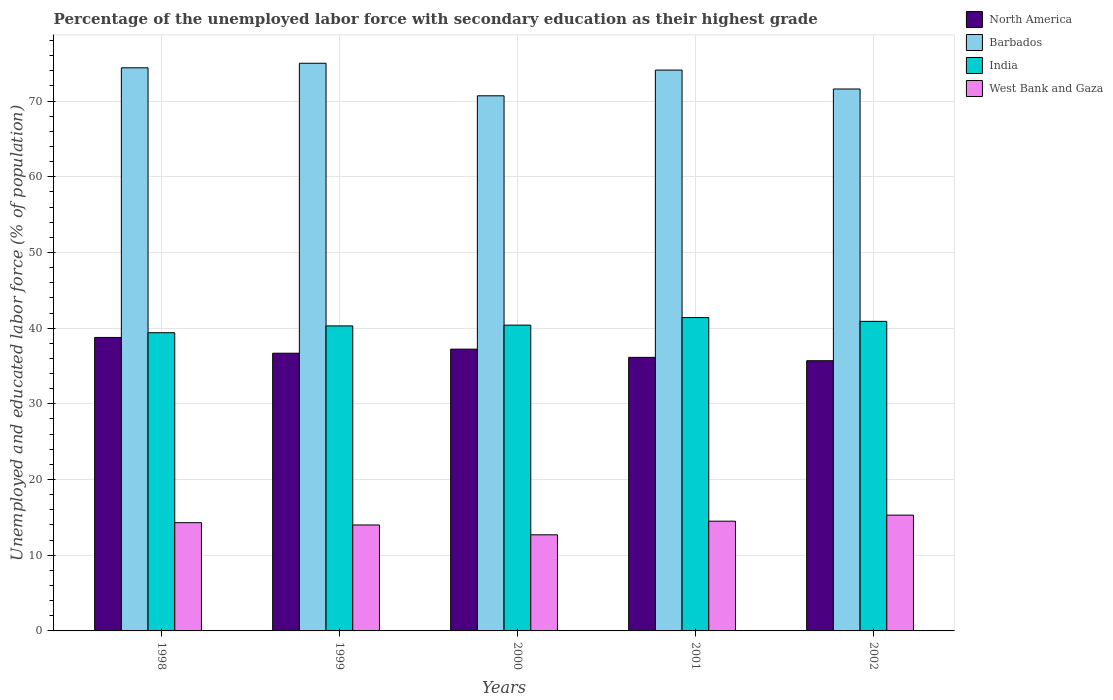How many different coloured bars are there?
Your answer should be compact. 4. Are the number of bars on each tick of the X-axis equal?
Provide a succinct answer. Yes. How many bars are there on the 4th tick from the right?
Your answer should be very brief. 4. What is the label of the 5th group of bars from the left?
Provide a short and direct response. 2002. What is the percentage of the unemployed labor force with secondary education in North America in 2001?
Provide a short and direct response. 36.14. Across all years, what is the maximum percentage of the unemployed labor force with secondary education in India?
Keep it short and to the point. 41.4. Across all years, what is the minimum percentage of the unemployed labor force with secondary education in West Bank and Gaza?
Offer a very short reply. 12.7. In which year was the percentage of the unemployed labor force with secondary education in West Bank and Gaza maximum?
Your response must be concise. 2002. In which year was the percentage of the unemployed labor force with secondary education in India minimum?
Provide a short and direct response. 1998. What is the total percentage of the unemployed labor force with secondary education in North America in the graph?
Make the answer very short. 184.53. What is the difference between the percentage of the unemployed labor force with secondary education in Barbados in 1998 and that in 2002?
Your answer should be compact. 2.8. What is the difference between the percentage of the unemployed labor force with secondary education in Barbados in 2000 and the percentage of the unemployed labor force with secondary education in West Bank and Gaza in 1998?
Provide a succinct answer. 56.4. What is the average percentage of the unemployed labor force with secondary education in India per year?
Provide a succinct answer. 40.48. In the year 1999, what is the difference between the percentage of the unemployed labor force with secondary education in Barbados and percentage of the unemployed labor force with secondary education in India?
Offer a terse response. 34.7. What is the ratio of the percentage of the unemployed labor force with secondary education in West Bank and Gaza in 1998 to that in 1999?
Offer a very short reply. 1.02. Is the percentage of the unemployed labor force with secondary education in North America in 1998 less than that in 2000?
Your response must be concise. No. Is the difference between the percentage of the unemployed labor force with secondary education in Barbados in 1998 and 2001 greater than the difference between the percentage of the unemployed labor force with secondary education in India in 1998 and 2001?
Keep it short and to the point. Yes. What is the difference between the highest and the second highest percentage of the unemployed labor force with secondary education in North America?
Ensure brevity in your answer.  1.55. What is the difference between the highest and the lowest percentage of the unemployed labor force with secondary education in North America?
Keep it short and to the point. 3.07. What does the 4th bar from the left in 2002 represents?
Your answer should be very brief. West Bank and Gaza. What does the 3rd bar from the right in 2001 represents?
Ensure brevity in your answer.  Barbados. Is it the case that in every year, the sum of the percentage of the unemployed labor force with secondary education in Barbados and percentage of the unemployed labor force with secondary education in North America is greater than the percentage of the unemployed labor force with secondary education in India?
Offer a very short reply. Yes. Are all the bars in the graph horizontal?
Provide a succinct answer. No. What is the difference between two consecutive major ticks on the Y-axis?
Offer a very short reply. 10. Does the graph contain any zero values?
Your response must be concise. No. Does the graph contain grids?
Give a very brief answer. Yes. Where does the legend appear in the graph?
Offer a terse response. Top right. How many legend labels are there?
Provide a short and direct response. 4. How are the legend labels stacked?
Offer a terse response. Vertical. What is the title of the graph?
Your answer should be compact. Percentage of the unemployed labor force with secondary education as their highest grade. What is the label or title of the X-axis?
Your answer should be very brief. Years. What is the label or title of the Y-axis?
Provide a short and direct response. Unemployed and educated labor force (% of population). What is the Unemployed and educated labor force (% of population) of North America in 1998?
Make the answer very short. 38.77. What is the Unemployed and educated labor force (% of population) of Barbados in 1998?
Give a very brief answer. 74.4. What is the Unemployed and educated labor force (% of population) of India in 1998?
Your response must be concise. 39.4. What is the Unemployed and educated labor force (% of population) in West Bank and Gaza in 1998?
Your answer should be very brief. 14.3. What is the Unemployed and educated labor force (% of population) in North America in 1999?
Provide a succinct answer. 36.69. What is the Unemployed and educated labor force (% of population) in India in 1999?
Your answer should be very brief. 40.3. What is the Unemployed and educated labor force (% of population) of North America in 2000?
Your response must be concise. 37.23. What is the Unemployed and educated labor force (% of population) in Barbados in 2000?
Your response must be concise. 70.7. What is the Unemployed and educated labor force (% of population) in India in 2000?
Your answer should be compact. 40.4. What is the Unemployed and educated labor force (% of population) of West Bank and Gaza in 2000?
Keep it short and to the point. 12.7. What is the Unemployed and educated labor force (% of population) in North America in 2001?
Give a very brief answer. 36.14. What is the Unemployed and educated labor force (% of population) of Barbados in 2001?
Your answer should be compact. 74.1. What is the Unemployed and educated labor force (% of population) in India in 2001?
Offer a very short reply. 41.4. What is the Unemployed and educated labor force (% of population) in West Bank and Gaza in 2001?
Your answer should be compact. 14.5. What is the Unemployed and educated labor force (% of population) of North America in 2002?
Provide a succinct answer. 35.7. What is the Unemployed and educated labor force (% of population) in Barbados in 2002?
Offer a very short reply. 71.6. What is the Unemployed and educated labor force (% of population) in India in 2002?
Your response must be concise. 40.9. What is the Unemployed and educated labor force (% of population) in West Bank and Gaza in 2002?
Offer a terse response. 15.3. Across all years, what is the maximum Unemployed and educated labor force (% of population) in North America?
Make the answer very short. 38.77. Across all years, what is the maximum Unemployed and educated labor force (% of population) in India?
Ensure brevity in your answer.  41.4. Across all years, what is the maximum Unemployed and educated labor force (% of population) of West Bank and Gaza?
Your answer should be compact. 15.3. Across all years, what is the minimum Unemployed and educated labor force (% of population) of North America?
Ensure brevity in your answer.  35.7. Across all years, what is the minimum Unemployed and educated labor force (% of population) of Barbados?
Provide a short and direct response. 70.7. Across all years, what is the minimum Unemployed and educated labor force (% of population) in India?
Your answer should be compact. 39.4. Across all years, what is the minimum Unemployed and educated labor force (% of population) in West Bank and Gaza?
Offer a very short reply. 12.7. What is the total Unemployed and educated labor force (% of population) of North America in the graph?
Provide a short and direct response. 184.53. What is the total Unemployed and educated labor force (% of population) in Barbados in the graph?
Your answer should be very brief. 365.8. What is the total Unemployed and educated labor force (% of population) of India in the graph?
Your response must be concise. 202.4. What is the total Unemployed and educated labor force (% of population) in West Bank and Gaza in the graph?
Your answer should be very brief. 70.8. What is the difference between the Unemployed and educated labor force (% of population) of North America in 1998 and that in 1999?
Offer a very short reply. 2.08. What is the difference between the Unemployed and educated labor force (% of population) of North America in 1998 and that in 2000?
Offer a terse response. 1.55. What is the difference between the Unemployed and educated labor force (% of population) in India in 1998 and that in 2000?
Keep it short and to the point. -1. What is the difference between the Unemployed and educated labor force (% of population) of West Bank and Gaza in 1998 and that in 2000?
Provide a short and direct response. 1.6. What is the difference between the Unemployed and educated labor force (% of population) in North America in 1998 and that in 2001?
Offer a terse response. 2.63. What is the difference between the Unemployed and educated labor force (% of population) of India in 1998 and that in 2001?
Provide a succinct answer. -2. What is the difference between the Unemployed and educated labor force (% of population) of West Bank and Gaza in 1998 and that in 2001?
Keep it short and to the point. -0.2. What is the difference between the Unemployed and educated labor force (% of population) of North America in 1998 and that in 2002?
Offer a terse response. 3.07. What is the difference between the Unemployed and educated labor force (% of population) in India in 1998 and that in 2002?
Offer a terse response. -1.5. What is the difference between the Unemployed and educated labor force (% of population) in West Bank and Gaza in 1998 and that in 2002?
Ensure brevity in your answer.  -1. What is the difference between the Unemployed and educated labor force (% of population) in North America in 1999 and that in 2000?
Keep it short and to the point. -0.54. What is the difference between the Unemployed and educated labor force (% of population) in India in 1999 and that in 2000?
Your answer should be very brief. -0.1. What is the difference between the Unemployed and educated labor force (% of population) in North America in 1999 and that in 2001?
Ensure brevity in your answer.  0.55. What is the difference between the Unemployed and educated labor force (% of population) in India in 1999 and that in 2002?
Give a very brief answer. -0.6. What is the difference between the Unemployed and educated labor force (% of population) in West Bank and Gaza in 1999 and that in 2002?
Provide a succinct answer. -1.3. What is the difference between the Unemployed and educated labor force (% of population) of North America in 2000 and that in 2001?
Your answer should be very brief. 1.08. What is the difference between the Unemployed and educated labor force (% of population) of Barbados in 2000 and that in 2001?
Provide a succinct answer. -3.4. What is the difference between the Unemployed and educated labor force (% of population) in India in 2000 and that in 2001?
Provide a succinct answer. -1. What is the difference between the Unemployed and educated labor force (% of population) of West Bank and Gaza in 2000 and that in 2001?
Make the answer very short. -1.8. What is the difference between the Unemployed and educated labor force (% of population) of North America in 2000 and that in 2002?
Keep it short and to the point. 1.53. What is the difference between the Unemployed and educated labor force (% of population) in Barbados in 2000 and that in 2002?
Give a very brief answer. -0.9. What is the difference between the Unemployed and educated labor force (% of population) in India in 2000 and that in 2002?
Make the answer very short. -0.5. What is the difference between the Unemployed and educated labor force (% of population) in West Bank and Gaza in 2000 and that in 2002?
Offer a very short reply. -2.6. What is the difference between the Unemployed and educated labor force (% of population) of North America in 2001 and that in 2002?
Your response must be concise. 0.44. What is the difference between the Unemployed and educated labor force (% of population) in West Bank and Gaza in 2001 and that in 2002?
Your answer should be compact. -0.8. What is the difference between the Unemployed and educated labor force (% of population) of North America in 1998 and the Unemployed and educated labor force (% of population) of Barbados in 1999?
Keep it short and to the point. -36.23. What is the difference between the Unemployed and educated labor force (% of population) in North America in 1998 and the Unemployed and educated labor force (% of population) in India in 1999?
Offer a terse response. -1.53. What is the difference between the Unemployed and educated labor force (% of population) in North America in 1998 and the Unemployed and educated labor force (% of population) in West Bank and Gaza in 1999?
Offer a very short reply. 24.77. What is the difference between the Unemployed and educated labor force (% of population) in Barbados in 1998 and the Unemployed and educated labor force (% of population) in India in 1999?
Make the answer very short. 34.1. What is the difference between the Unemployed and educated labor force (% of population) in Barbados in 1998 and the Unemployed and educated labor force (% of population) in West Bank and Gaza in 1999?
Ensure brevity in your answer.  60.4. What is the difference between the Unemployed and educated labor force (% of population) in India in 1998 and the Unemployed and educated labor force (% of population) in West Bank and Gaza in 1999?
Provide a short and direct response. 25.4. What is the difference between the Unemployed and educated labor force (% of population) in North America in 1998 and the Unemployed and educated labor force (% of population) in Barbados in 2000?
Provide a succinct answer. -31.93. What is the difference between the Unemployed and educated labor force (% of population) of North America in 1998 and the Unemployed and educated labor force (% of population) of India in 2000?
Keep it short and to the point. -1.63. What is the difference between the Unemployed and educated labor force (% of population) in North America in 1998 and the Unemployed and educated labor force (% of population) in West Bank and Gaza in 2000?
Offer a terse response. 26.07. What is the difference between the Unemployed and educated labor force (% of population) of Barbados in 1998 and the Unemployed and educated labor force (% of population) of India in 2000?
Give a very brief answer. 34. What is the difference between the Unemployed and educated labor force (% of population) in Barbados in 1998 and the Unemployed and educated labor force (% of population) in West Bank and Gaza in 2000?
Ensure brevity in your answer.  61.7. What is the difference between the Unemployed and educated labor force (% of population) in India in 1998 and the Unemployed and educated labor force (% of population) in West Bank and Gaza in 2000?
Offer a terse response. 26.7. What is the difference between the Unemployed and educated labor force (% of population) of North America in 1998 and the Unemployed and educated labor force (% of population) of Barbados in 2001?
Ensure brevity in your answer.  -35.33. What is the difference between the Unemployed and educated labor force (% of population) of North America in 1998 and the Unemployed and educated labor force (% of population) of India in 2001?
Offer a terse response. -2.63. What is the difference between the Unemployed and educated labor force (% of population) in North America in 1998 and the Unemployed and educated labor force (% of population) in West Bank and Gaza in 2001?
Offer a terse response. 24.27. What is the difference between the Unemployed and educated labor force (% of population) of Barbados in 1998 and the Unemployed and educated labor force (% of population) of India in 2001?
Your answer should be very brief. 33. What is the difference between the Unemployed and educated labor force (% of population) of Barbados in 1998 and the Unemployed and educated labor force (% of population) of West Bank and Gaza in 2001?
Keep it short and to the point. 59.9. What is the difference between the Unemployed and educated labor force (% of population) of India in 1998 and the Unemployed and educated labor force (% of population) of West Bank and Gaza in 2001?
Provide a succinct answer. 24.9. What is the difference between the Unemployed and educated labor force (% of population) of North America in 1998 and the Unemployed and educated labor force (% of population) of Barbados in 2002?
Give a very brief answer. -32.83. What is the difference between the Unemployed and educated labor force (% of population) in North America in 1998 and the Unemployed and educated labor force (% of population) in India in 2002?
Ensure brevity in your answer.  -2.13. What is the difference between the Unemployed and educated labor force (% of population) in North America in 1998 and the Unemployed and educated labor force (% of population) in West Bank and Gaza in 2002?
Offer a very short reply. 23.47. What is the difference between the Unemployed and educated labor force (% of population) of Barbados in 1998 and the Unemployed and educated labor force (% of population) of India in 2002?
Offer a very short reply. 33.5. What is the difference between the Unemployed and educated labor force (% of population) in Barbados in 1998 and the Unemployed and educated labor force (% of population) in West Bank and Gaza in 2002?
Your answer should be compact. 59.1. What is the difference between the Unemployed and educated labor force (% of population) in India in 1998 and the Unemployed and educated labor force (% of population) in West Bank and Gaza in 2002?
Make the answer very short. 24.1. What is the difference between the Unemployed and educated labor force (% of population) in North America in 1999 and the Unemployed and educated labor force (% of population) in Barbados in 2000?
Offer a terse response. -34.01. What is the difference between the Unemployed and educated labor force (% of population) of North America in 1999 and the Unemployed and educated labor force (% of population) of India in 2000?
Your answer should be very brief. -3.71. What is the difference between the Unemployed and educated labor force (% of population) in North America in 1999 and the Unemployed and educated labor force (% of population) in West Bank and Gaza in 2000?
Your answer should be compact. 23.99. What is the difference between the Unemployed and educated labor force (% of population) of Barbados in 1999 and the Unemployed and educated labor force (% of population) of India in 2000?
Make the answer very short. 34.6. What is the difference between the Unemployed and educated labor force (% of population) of Barbados in 1999 and the Unemployed and educated labor force (% of population) of West Bank and Gaza in 2000?
Offer a very short reply. 62.3. What is the difference between the Unemployed and educated labor force (% of population) in India in 1999 and the Unemployed and educated labor force (% of population) in West Bank and Gaza in 2000?
Your answer should be compact. 27.6. What is the difference between the Unemployed and educated labor force (% of population) of North America in 1999 and the Unemployed and educated labor force (% of population) of Barbados in 2001?
Ensure brevity in your answer.  -37.41. What is the difference between the Unemployed and educated labor force (% of population) of North America in 1999 and the Unemployed and educated labor force (% of population) of India in 2001?
Your answer should be very brief. -4.71. What is the difference between the Unemployed and educated labor force (% of population) of North America in 1999 and the Unemployed and educated labor force (% of population) of West Bank and Gaza in 2001?
Provide a short and direct response. 22.19. What is the difference between the Unemployed and educated labor force (% of population) of Barbados in 1999 and the Unemployed and educated labor force (% of population) of India in 2001?
Offer a terse response. 33.6. What is the difference between the Unemployed and educated labor force (% of population) in Barbados in 1999 and the Unemployed and educated labor force (% of population) in West Bank and Gaza in 2001?
Your answer should be compact. 60.5. What is the difference between the Unemployed and educated labor force (% of population) in India in 1999 and the Unemployed and educated labor force (% of population) in West Bank and Gaza in 2001?
Offer a terse response. 25.8. What is the difference between the Unemployed and educated labor force (% of population) of North America in 1999 and the Unemployed and educated labor force (% of population) of Barbados in 2002?
Offer a very short reply. -34.91. What is the difference between the Unemployed and educated labor force (% of population) in North America in 1999 and the Unemployed and educated labor force (% of population) in India in 2002?
Make the answer very short. -4.21. What is the difference between the Unemployed and educated labor force (% of population) in North America in 1999 and the Unemployed and educated labor force (% of population) in West Bank and Gaza in 2002?
Keep it short and to the point. 21.39. What is the difference between the Unemployed and educated labor force (% of population) of Barbados in 1999 and the Unemployed and educated labor force (% of population) of India in 2002?
Provide a short and direct response. 34.1. What is the difference between the Unemployed and educated labor force (% of population) in Barbados in 1999 and the Unemployed and educated labor force (% of population) in West Bank and Gaza in 2002?
Provide a short and direct response. 59.7. What is the difference between the Unemployed and educated labor force (% of population) in India in 1999 and the Unemployed and educated labor force (% of population) in West Bank and Gaza in 2002?
Make the answer very short. 25. What is the difference between the Unemployed and educated labor force (% of population) of North America in 2000 and the Unemployed and educated labor force (% of population) of Barbados in 2001?
Provide a short and direct response. -36.87. What is the difference between the Unemployed and educated labor force (% of population) in North America in 2000 and the Unemployed and educated labor force (% of population) in India in 2001?
Keep it short and to the point. -4.17. What is the difference between the Unemployed and educated labor force (% of population) in North America in 2000 and the Unemployed and educated labor force (% of population) in West Bank and Gaza in 2001?
Make the answer very short. 22.73. What is the difference between the Unemployed and educated labor force (% of population) of Barbados in 2000 and the Unemployed and educated labor force (% of population) of India in 2001?
Your response must be concise. 29.3. What is the difference between the Unemployed and educated labor force (% of population) of Barbados in 2000 and the Unemployed and educated labor force (% of population) of West Bank and Gaza in 2001?
Keep it short and to the point. 56.2. What is the difference between the Unemployed and educated labor force (% of population) of India in 2000 and the Unemployed and educated labor force (% of population) of West Bank and Gaza in 2001?
Keep it short and to the point. 25.9. What is the difference between the Unemployed and educated labor force (% of population) of North America in 2000 and the Unemployed and educated labor force (% of population) of Barbados in 2002?
Provide a short and direct response. -34.37. What is the difference between the Unemployed and educated labor force (% of population) of North America in 2000 and the Unemployed and educated labor force (% of population) of India in 2002?
Keep it short and to the point. -3.67. What is the difference between the Unemployed and educated labor force (% of population) of North America in 2000 and the Unemployed and educated labor force (% of population) of West Bank and Gaza in 2002?
Offer a terse response. 21.93. What is the difference between the Unemployed and educated labor force (% of population) of Barbados in 2000 and the Unemployed and educated labor force (% of population) of India in 2002?
Make the answer very short. 29.8. What is the difference between the Unemployed and educated labor force (% of population) in Barbados in 2000 and the Unemployed and educated labor force (% of population) in West Bank and Gaza in 2002?
Make the answer very short. 55.4. What is the difference between the Unemployed and educated labor force (% of population) in India in 2000 and the Unemployed and educated labor force (% of population) in West Bank and Gaza in 2002?
Provide a succinct answer. 25.1. What is the difference between the Unemployed and educated labor force (% of population) in North America in 2001 and the Unemployed and educated labor force (% of population) in Barbados in 2002?
Offer a very short reply. -35.46. What is the difference between the Unemployed and educated labor force (% of population) of North America in 2001 and the Unemployed and educated labor force (% of population) of India in 2002?
Offer a terse response. -4.76. What is the difference between the Unemployed and educated labor force (% of population) in North America in 2001 and the Unemployed and educated labor force (% of population) in West Bank and Gaza in 2002?
Keep it short and to the point. 20.84. What is the difference between the Unemployed and educated labor force (% of population) of Barbados in 2001 and the Unemployed and educated labor force (% of population) of India in 2002?
Provide a short and direct response. 33.2. What is the difference between the Unemployed and educated labor force (% of population) of Barbados in 2001 and the Unemployed and educated labor force (% of population) of West Bank and Gaza in 2002?
Provide a succinct answer. 58.8. What is the difference between the Unemployed and educated labor force (% of population) in India in 2001 and the Unemployed and educated labor force (% of population) in West Bank and Gaza in 2002?
Offer a very short reply. 26.1. What is the average Unemployed and educated labor force (% of population) in North America per year?
Offer a very short reply. 36.91. What is the average Unemployed and educated labor force (% of population) of Barbados per year?
Your answer should be compact. 73.16. What is the average Unemployed and educated labor force (% of population) in India per year?
Your response must be concise. 40.48. What is the average Unemployed and educated labor force (% of population) of West Bank and Gaza per year?
Ensure brevity in your answer.  14.16. In the year 1998, what is the difference between the Unemployed and educated labor force (% of population) of North America and Unemployed and educated labor force (% of population) of Barbados?
Provide a short and direct response. -35.63. In the year 1998, what is the difference between the Unemployed and educated labor force (% of population) of North America and Unemployed and educated labor force (% of population) of India?
Provide a succinct answer. -0.63. In the year 1998, what is the difference between the Unemployed and educated labor force (% of population) in North America and Unemployed and educated labor force (% of population) in West Bank and Gaza?
Keep it short and to the point. 24.47. In the year 1998, what is the difference between the Unemployed and educated labor force (% of population) in Barbados and Unemployed and educated labor force (% of population) in India?
Your answer should be compact. 35. In the year 1998, what is the difference between the Unemployed and educated labor force (% of population) in Barbados and Unemployed and educated labor force (% of population) in West Bank and Gaza?
Your answer should be compact. 60.1. In the year 1998, what is the difference between the Unemployed and educated labor force (% of population) in India and Unemployed and educated labor force (% of population) in West Bank and Gaza?
Offer a very short reply. 25.1. In the year 1999, what is the difference between the Unemployed and educated labor force (% of population) in North America and Unemployed and educated labor force (% of population) in Barbados?
Ensure brevity in your answer.  -38.31. In the year 1999, what is the difference between the Unemployed and educated labor force (% of population) of North America and Unemployed and educated labor force (% of population) of India?
Your response must be concise. -3.61. In the year 1999, what is the difference between the Unemployed and educated labor force (% of population) in North America and Unemployed and educated labor force (% of population) in West Bank and Gaza?
Make the answer very short. 22.69. In the year 1999, what is the difference between the Unemployed and educated labor force (% of population) in Barbados and Unemployed and educated labor force (% of population) in India?
Keep it short and to the point. 34.7. In the year 1999, what is the difference between the Unemployed and educated labor force (% of population) in India and Unemployed and educated labor force (% of population) in West Bank and Gaza?
Offer a terse response. 26.3. In the year 2000, what is the difference between the Unemployed and educated labor force (% of population) in North America and Unemployed and educated labor force (% of population) in Barbados?
Your answer should be very brief. -33.47. In the year 2000, what is the difference between the Unemployed and educated labor force (% of population) of North America and Unemployed and educated labor force (% of population) of India?
Keep it short and to the point. -3.17. In the year 2000, what is the difference between the Unemployed and educated labor force (% of population) of North America and Unemployed and educated labor force (% of population) of West Bank and Gaza?
Make the answer very short. 24.53. In the year 2000, what is the difference between the Unemployed and educated labor force (% of population) in Barbados and Unemployed and educated labor force (% of population) in India?
Ensure brevity in your answer.  30.3. In the year 2000, what is the difference between the Unemployed and educated labor force (% of population) of Barbados and Unemployed and educated labor force (% of population) of West Bank and Gaza?
Give a very brief answer. 58. In the year 2000, what is the difference between the Unemployed and educated labor force (% of population) in India and Unemployed and educated labor force (% of population) in West Bank and Gaza?
Offer a very short reply. 27.7. In the year 2001, what is the difference between the Unemployed and educated labor force (% of population) of North America and Unemployed and educated labor force (% of population) of Barbados?
Provide a short and direct response. -37.96. In the year 2001, what is the difference between the Unemployed and educated labor force (% of population) of North America and Unemployed and educated labor force (% of population) of India?
Your answer should be compact. -5.26. In the year 2001, what is the difference between the Unemployed and educated labor force (% of population) of North America and Unemployed and educated labor force (% of population) of West Bank and Gaza?
Your answer should be compact. 21.64. In the year 2001, what is the difference between the Unemployed and educated labor force (% of population) of Barbados and Unemployed and educated labor force (% of population) of India?
Keep it short and to the point. 32.7. In the year 2001, what is the difference between the Unemployed and educated labor force (% of population) of Barbados and Unemployed and educated labor force (% of population) of West Bank and Gaza?
Keep it short and to the point. 59.6. In the year 2001, what is the difference between the Unemployed and educated labor force (% of population) in India and Unemployed and educated labor force (% of population) in West Bank and Gaza?
Your answer should be very brief. 26.9. In the year 2002, what is the difference between the Unemployed and educated labor force (% of population) in North America and Unemployed and educated labor force (% of population) in Barbados?
Your response must be concise. -35.9. In the year 2002, what is the difference between the Unemployed and educated labor force (% of population) of North America and Unemployed and educated labor force (% of population) of India?
Your response must be concise. -5.2. In the year 2002, what is the difference between the Unemployed and educated labor force (% of population) of North America and Unemployed and educated labor force (% of population) of West Bank and Gaza?
Your answer should be compact. 20.4. In the year 2002, what is the difference between the Unemployed and educated labor force (% of population) in Barbados and Unemployed and educated labor force (% of population) in India?
Make the answer very short. 30.7. In the year 2002, what is the difference between the Unemployed and educated labor force (% of population) of Barbados and Unemployed and educated labor force (% of population) of West Bank and Gaza?
Offer a very short reply. 56.3. In the year 2002, what is the difference between the Unemployed and educated labor force (% of population) in India and Unemployed and educated labor force (% of population) in West Bank and Gaza?
Offer a terse response. 25.6. What is the ratio of the Unemployed and educated labor force (% of population) of North America in 1998 to that in 1999?
Offer a terse response. 1.06. What is the ratio of the Unemployed and educated labor force (% of population) of India in 1998 to that in 1999?
Offer a very short reply. 0.98. What is the ratio of the Unemployed and educated labor force (% of population) of West Bank and Gaza in 1998 to that in 1999?
Give a very brief answer. 1.02. What is the ratio of the Unemployed and educated labor force (% of population) of North America in 1998 to that in 2000?
Your response must be concise. 1.04. What is the ratio of the Unemployed and educated labor force (% of population) of Barbados in 1998 to that in 2000?
Your answer should be very brief. 1.05. What is the ratio of the Unemployed and educated labor force (% of population) in India in 1998 to that in 2000?
Your answer should be compact. 0.98. What is the ratio of the Unemployed and educated labor force (% of population) in West Bank and Gaza in 1998 to that in 2000?
Keep it short and to the point. 1.13. What is the ratio of the Unemployed and educated labor force (% of population) of North America in 1998 to that in 2001?
Offer a terse response. 1.07. What is the ratio of the Unemployed and educated labor force (% of population) in India in 1998 to that in 2001?
Keep it short and to the point. 0.95. What is the ratio of the Unemployed and educated labor force (% of population) of West Bank and Gaza in 1998 to that in 2001?
Offer a very short reply. 0.99. What is the ratio of the Unemployed and educated labor force (% of population) in North America in 1998 to that in 2002?
Offer a very short reply. 1.09. What is the ratio of the Unemployed and educated labor force (% of population) of Barbados in 1998 to that in 2002?
Your response must be concise. 1.04. What is the ratio of the Unemployed and educated labor force (% of population) of India in 1998 to that in 2002?
Make the answer very short. 0.96. What is the ratio of the Unemployed and educated labor force (% of population) of West Bank and Gaza in 1998 to that in 2002?
Your answer should be very brief. 0.93. What is the ratio of the Unemployed and educated labor force (% of population) of North America in 1999 to that in 2000?
Give a very brief answer. 0.99. What is the ratio of the Unemployed and educated labor force (% of population) of Barbados in 1999 to that in 2000?
Provide a short and direct response. 1.06. What is the ratio of the Unemployed and educated labor force (% of population) in West Bank and Gaza in 1999 to that in 2000?
Your answer should be very brief. 1.1. What is the ratio of the Unemployed and educated labor force (% of population) in North America in 1999 to that in 2001?
Keep it short and to the point. 1.02. What is the ratio of the Unemployed and educated labor force (% of population) of Barbados in 1999 to that in 2001?
Make the answer very short. 1.01. What is the ratio of the Unemployed and educated labor force (% of population) of India in 1999 to that in 2001?
Give a very brief answer. 0.97. What is the ratio of the Unemployed and educated labor force (% of population) in West Bank and Gaza in 1999 to that in 2001?
Your response must be concise. 0.97. What is the ratio of the Unemployed and educated labor force (% of population) in North America in 1999 to that in 2002?
Give a very brief answer. 1.03. What is the ratio of the Unemployed and educated labor force (% of population) in Barbados in 1999 to that in 2002?
Provide a succinct answer. 1.05. What is the ratio of the Unemployed and educated labor force (% of population) in India in 1999 to that in 2002?
Keep it short and to the point. 0.99. What is the ratio of the Unemployed and educated labor force (% of population) of West Bank and Gaza in 1999 to that in 2002?
Ensure brevity in your answer.  0.92. What is the ratio of the Unemployed and educated labor force (% of population) of North America in 2000 to that in 2001?
Ensure brevity in your answer.  1.03. What is the ratio of the Unemployed and educated labor force (% of population) in Barbados in 2000 to that in 2001?
Your response must be concise. 0.95. What is the ratio of the Unemployed and educated labor force (% of population) in India in 2000 to that in 2001?
Offer a terse response. 0.98. What is the ratio of the Unemployed and educated labor force (% of population) of West Bank and Gaza in 2000 to that in 2001?
Your answer should be compact. 0.88. What is the ratio of the Unemployed and educated labor force (% of population) in North America in 2000 to that in 2002?
Provide a succinct answer. 1.04. What is the ratio of the Unemployed and educated labor force (% of population) in Barbados in 2000 to that in 2002?
Ensure brevity in your answer.  0.99. What is the ratio of the Unemployed and educated labor force (% of population) in West Bank and Gaza in 2000 to that in 2002?
Offer a very short reply. 0.83. What is the ratio of the Unemployed and educated labor force (% of population) of North America in 2001 to that in 2002?
Ensure brevity in your answer.  1.01. What is the ratio of the Unemployed and educated labor force (% of population) of Barbados in 2001 to that in 2002?
Offer a very short reply. 1.03. What is the ratio of the Unemployed and educated labor force (% of population) in India in 2001 to that in 2002?
Offer a very short reply. 1.01. What is the ratio of the Unemployed and educated labor force (% of population) of West Bank and Gaza in 2001 to that in 2002?
Keep it short and to the point. 0.95. What is the difference between the highest and the second highest Unemployed and educated labor force (% of population) of North America?
Ensure brevity in your answer.  1.55. What is the difference between the highest and the second highest Unemployed and educated labor force (% of population) of Barbados?
Offer a very short reply. 0.6. What is the difference between the highest and the second highest Unemployed and educated labor force (% of population) in India?
Your response must be concise. 0.5. What is the difference between the highest and the lowest Unemployed and educated labor force (% of population) in North America?
Your answer should be very brief. 3.07. What is the difference between the highest and the lowest Unemployed and educated labor force (% of population) of West Bank and Gaza?
Provide a succinct answer. 2.6. 